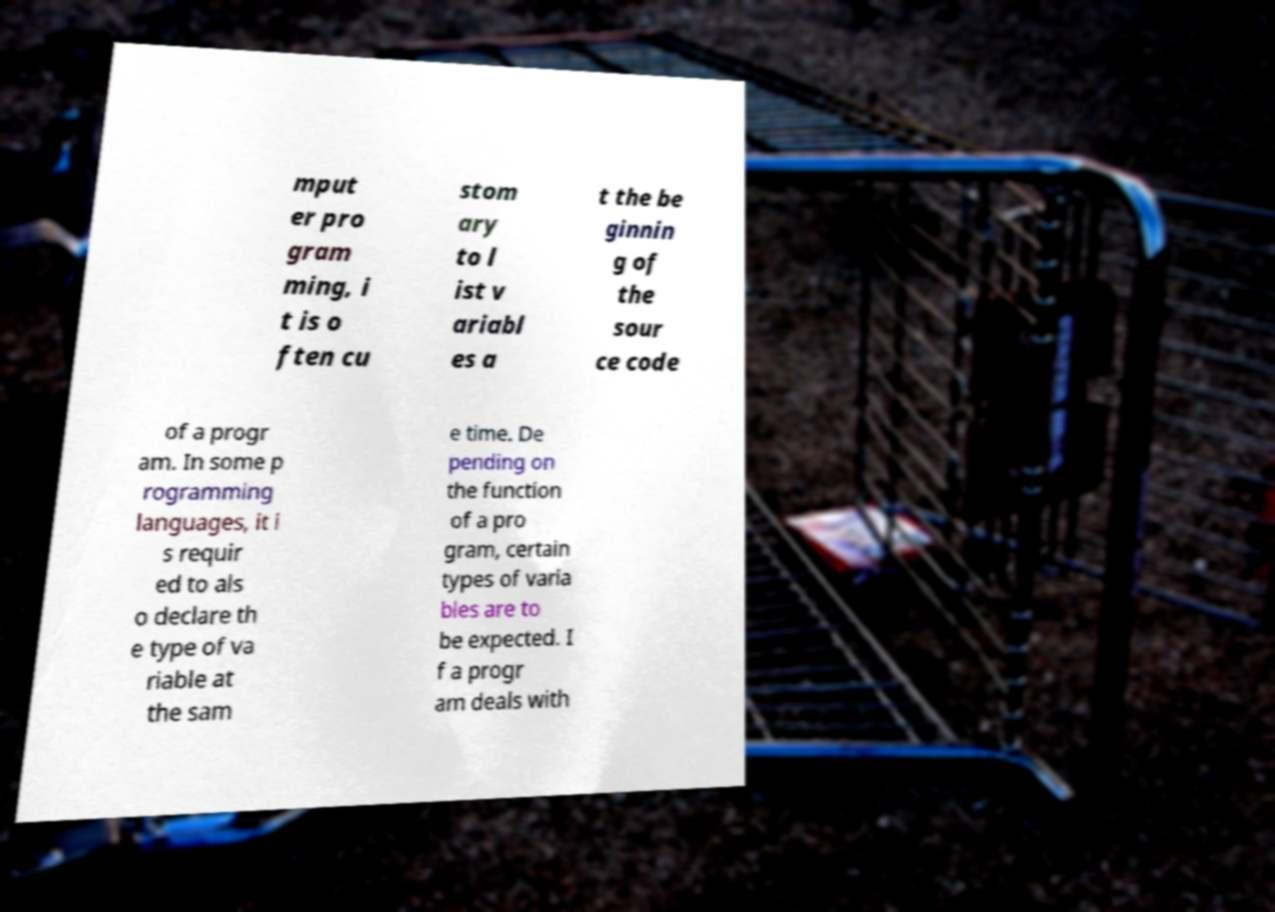Can you read and provide the text displayed in the image?This photo seems to have some interesting text. Can you extract and type it out for me? mput er pro gram ming, i t is o ften cu stom ary to l ist v ariabl es a t the be ginnin g of the sour ce code of a progr am. In some p rogramming languages, it i s requir ed to als o declare th e type of va riable at the sam e time. De pending on the function of a pro gram, certain types of varia bles are to be expected. I f a progr am deals with 